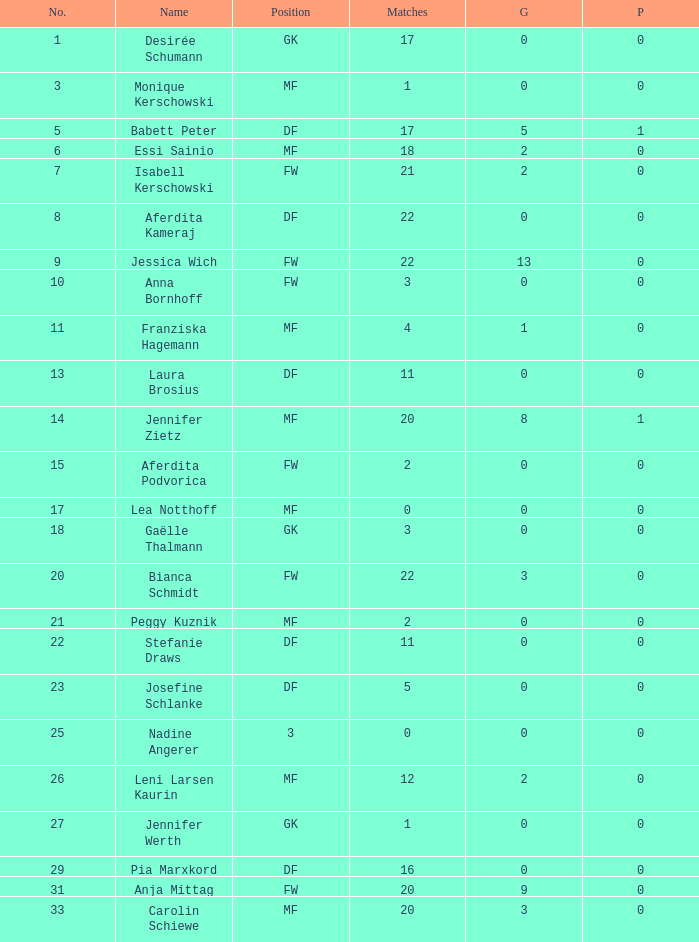What is the average goals for Essi Sainio? 2.0. 